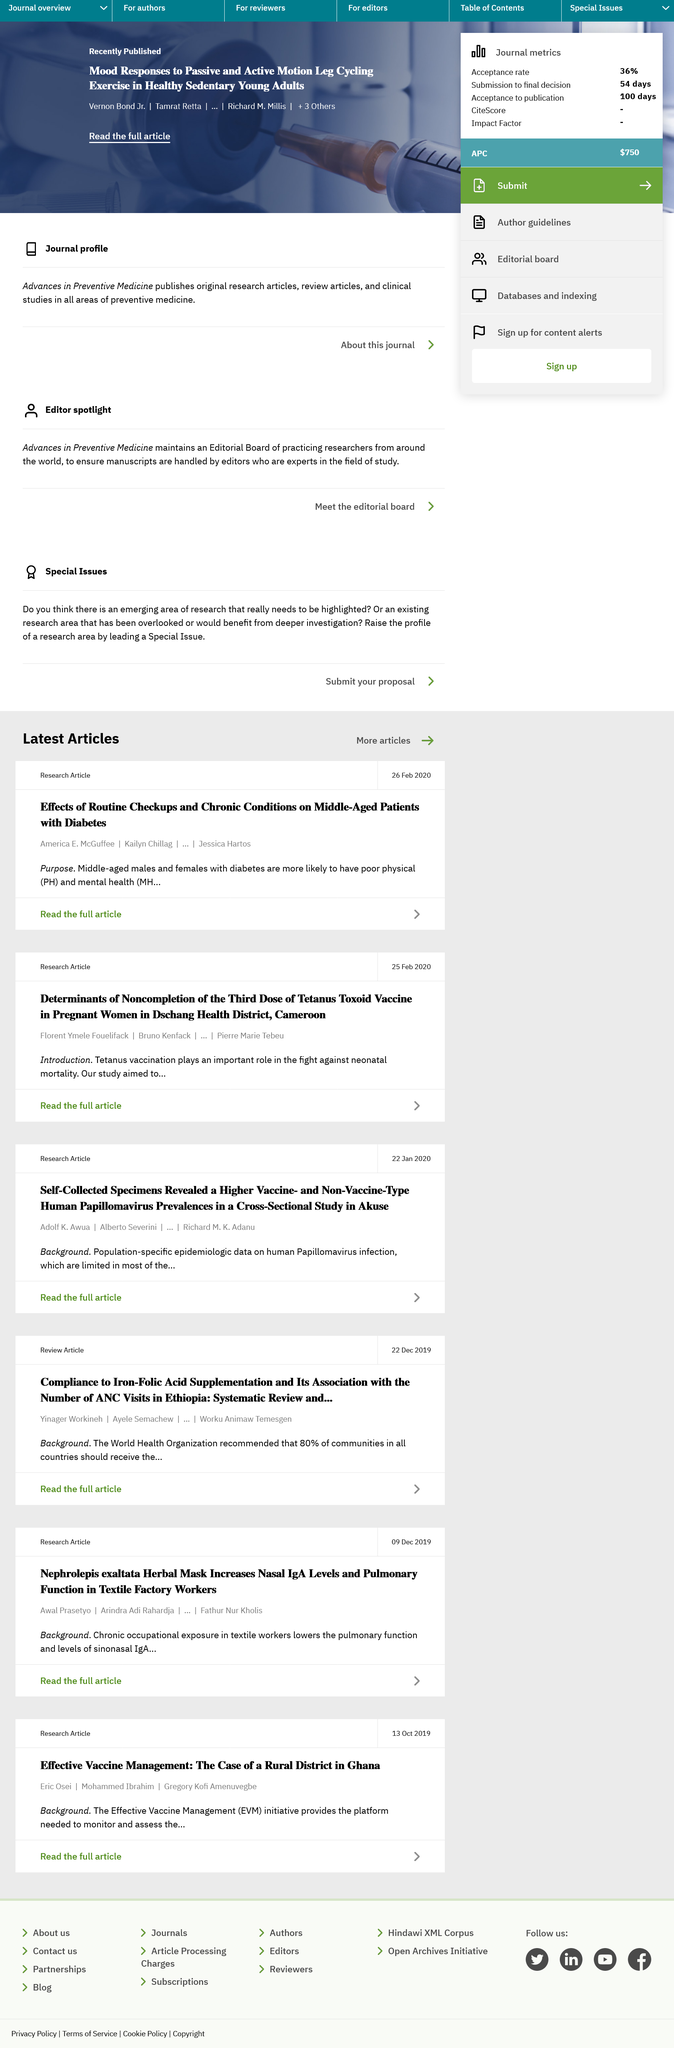Point out several critical features in this image. Tetanus vaccinations are crucial in combating neonatal mortality. The research article was published on February 25, 2020. The Dschang Health District is located in Cameroon. 